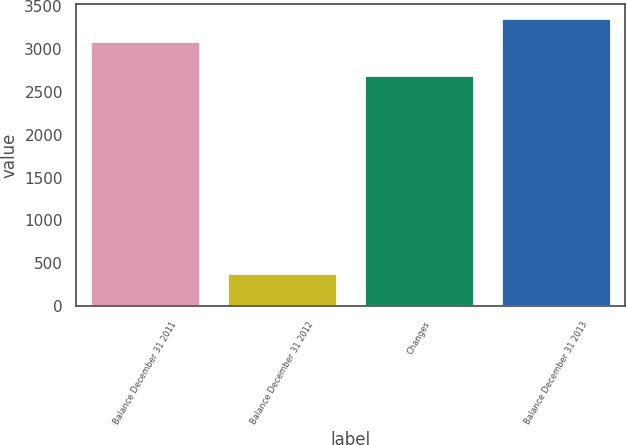Convert chart. <chart><loc_0><loc_0><loc_500><loc_500><bar_chart><fcel>Balance December 31 2011<fcel>Balance December 31 2012<fcel>Changes<fcel>Balance December 31 2013<nl><fcel>3084<fcel>388<fcel>2697<fcel>3353.7<nl></chart> 